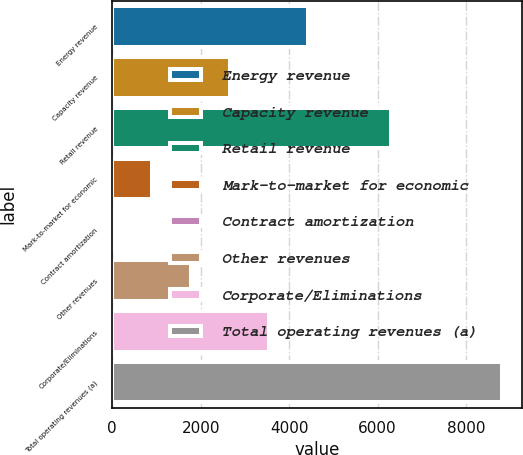<chart> <loc_0><loc_0><loc_500><loc_500><bar_chart><fcel>Energy revenue<fcel>Capacity revenue<fcel>Retail revenue<fcel>Mark-to-market for economic<fcel>Contract amortization<fcel>Other revenues<fcel>Corporate/Eliminations<fcel>Total operating revenues (a)<nl><fcel>4426<fcel>2668.4<fcel>6315<fcel>910.8<fcel>32<fcel>1789.6<fcel>3547.2<fcel>8820<nl></chart> 